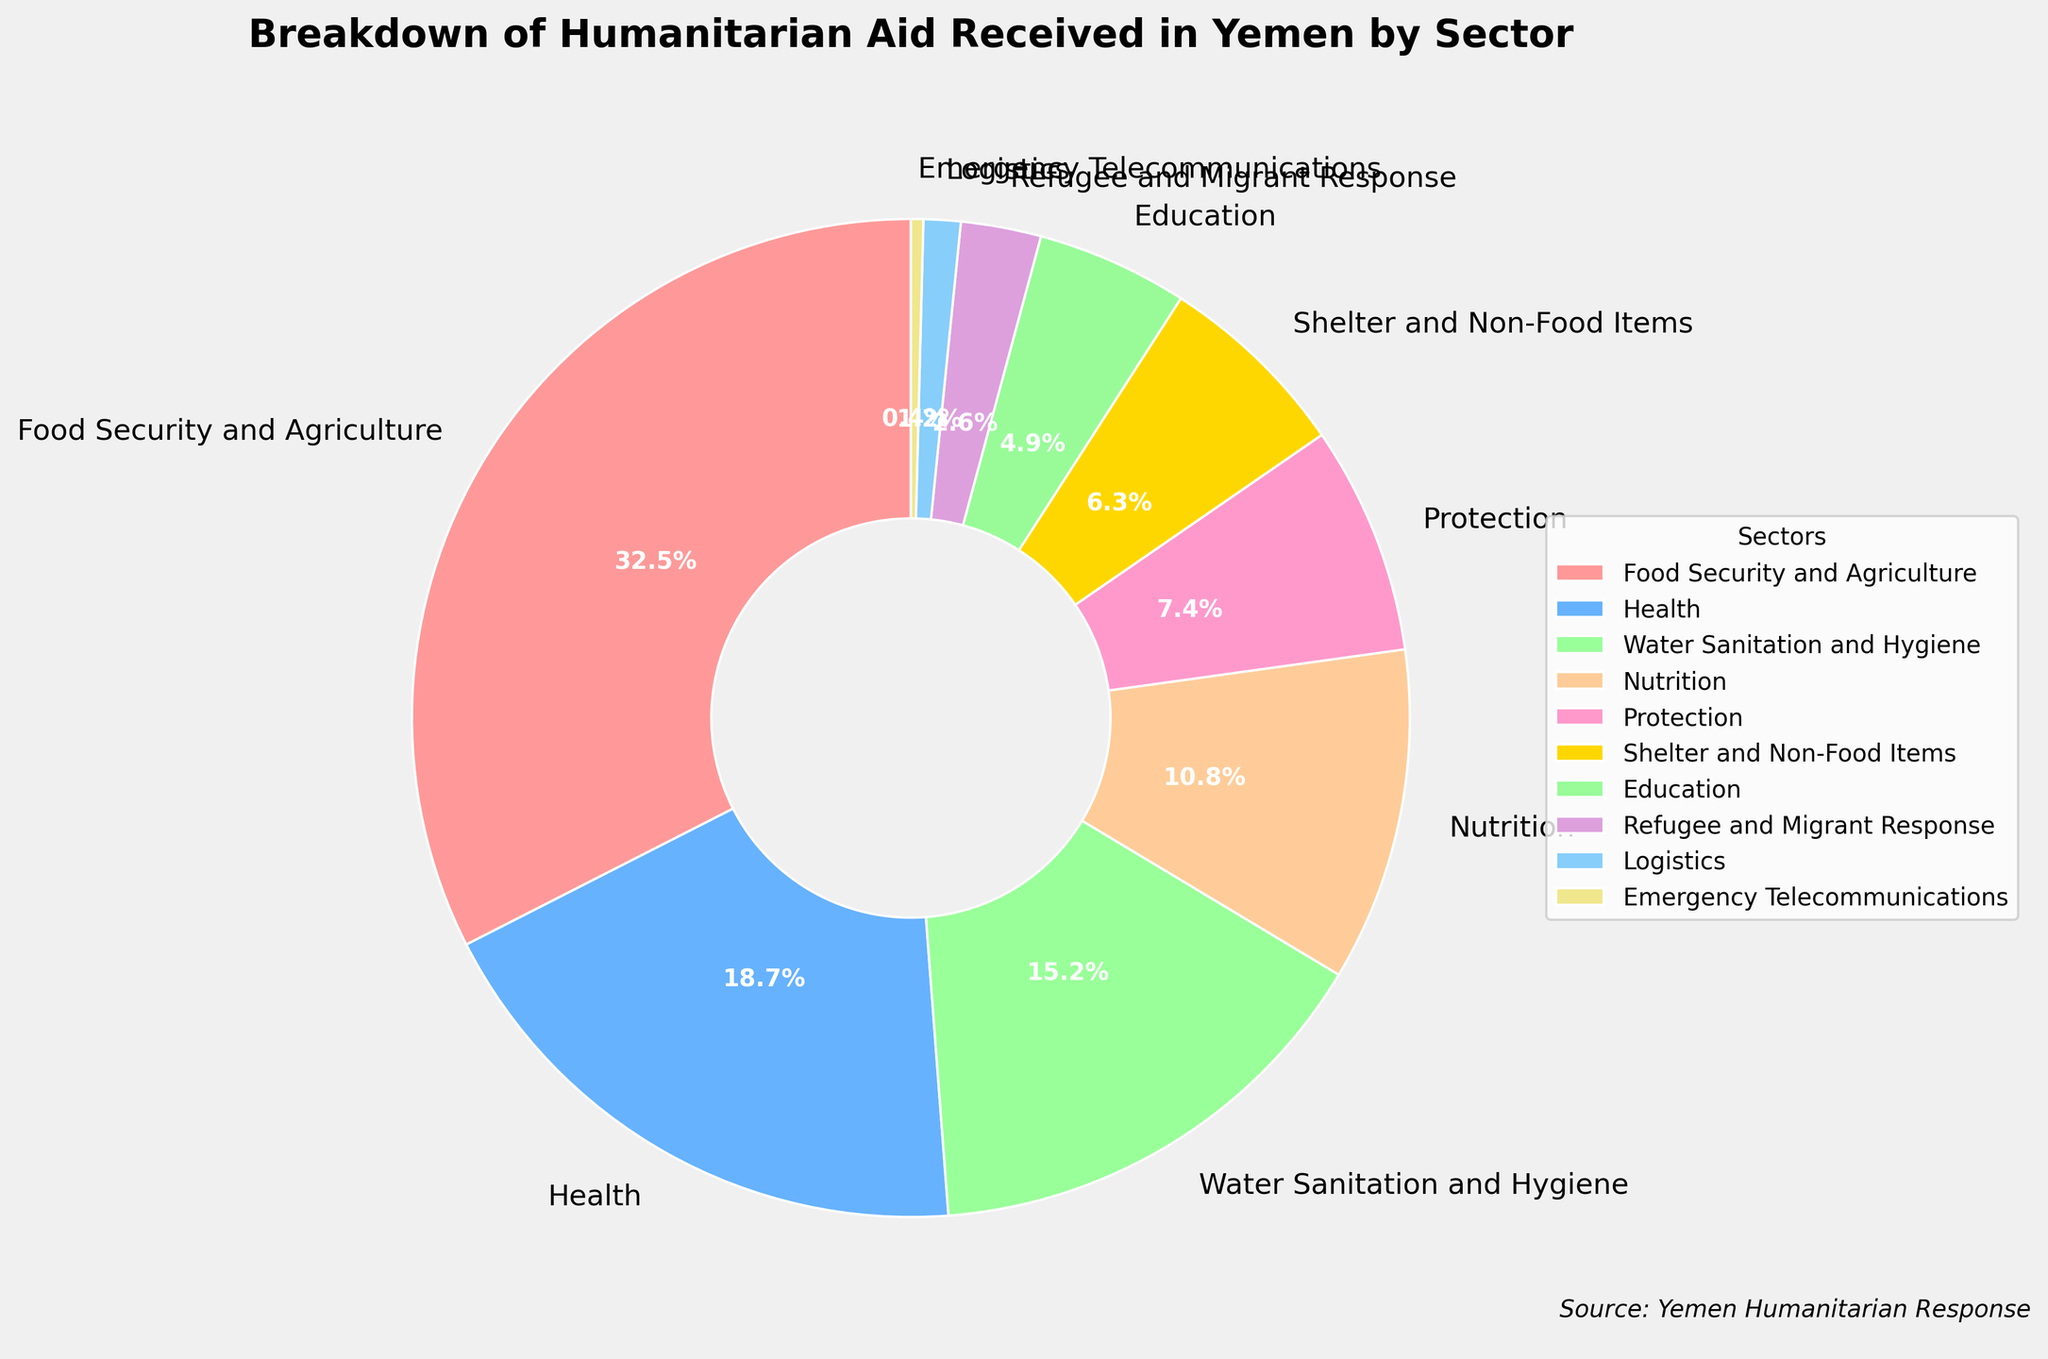Which sector receives the highest percentage of humanitarian aid? The figure shows a pie chart with labels and percentages for each sector. The sector with the highest value is labeled.
Answer: Food Security and Agriculture What is the combined percentage of aid received by Health and Water Sanitation and Hygiene? Add the percentage for Health (18.7%) and Water Sanitation and Hygiene (15.2%). This is a straightforward addition.
Answer: 33.9% How much more aid does the Food Security and Agriculture sector receive compared to the Nutrition sector? Subtract the percentage of Nutrition (10.8%) from the percentage of Food Security and Agriculture (32.5%).
Answer: 21.7% Which sectors receive less than 5% of the total humanitarian aid? Identify the segments in the pie chart with percentages below 5%. The corresponding sectors are labeled on the chart.
Answer: Education, Refugee and Migrant Response, Logistics, Emergency Telecommunications What is the average percentage of aid received by Protection, Shelter and Non-Food Items, and Education? Add the percentages of Protection (7.4%), Shelter and Non-Food Items (6.3%), and Education (4.9%) and divide by 3 to find the average.
Answer: 6.2% Which sector uses a golden color in the chart, and what is its percentage? The pie chart uses colors to differentiate sectors. Identify the segment colored in gold.
Answer: Shelter and Non-Food Items, 6.3% If the percentages for Food Security and Agriculture and Health are combined, what fraction of the total aid does this represent? Add the percentages for Food Security and Agriculture (32.5%) and Health (18.7%) to find the combined percentage. Then convert this percentage to a fraction by dividing by 100.
Answer: 51.2%, approximately 51/100 Is the percentage of aid allocated to Nutrition greater than twice that of Logistics? Compare twice the percentage of Logistics (1.2% * 2 = 2.4%) to the percentage of Nutrition (10.8%). Since 10.8% is greater than 2.4%, the answer is yes.
Answer: Yes What sectors receive more aid than Education? Identify sectors whose percentages are greater than Education’s 4.9%.
Answer: Food Security and Agriculture, Health, Water Sanitation and Hygiene, Nutrition, Protection, Shelter and Non-Food Items How does the percentage of aid allocated to Shelter and Non-Food Items compare to Refugee and Migrant Response? Compare the percentages. Shelter and Non-Food Items receive 6.3% and Refugee and Migrant Response receive 2.6%. 6.3% is greater than 2.6%.
Answer: Shelter and Non-Food Items receive more 